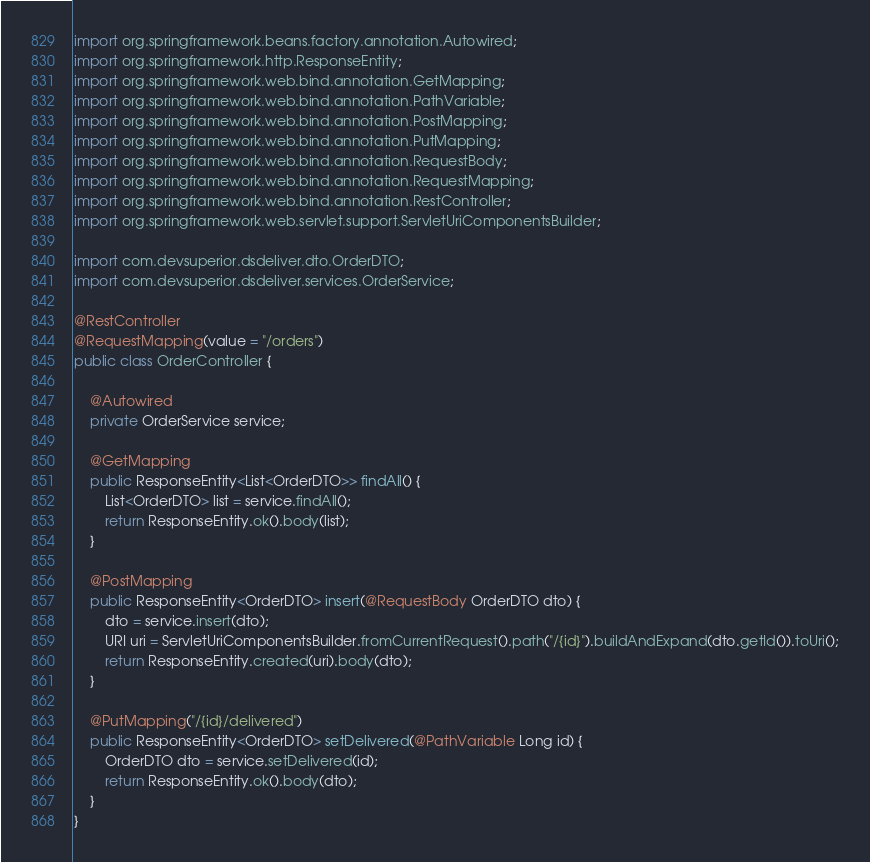<code> <loc_0><loc_0><loc_500><loc_500><_Java_>import org.springframework.beans.factory.annotation.Autowired;
import org.springframework.http.ResponseEntity;
import org.springframework.web.bind.annotation.GetMapping;
import org.springframework.web.bind.annotation.PathVariable;
import org.springframework.web.bind.annotation.PostMapping;
import org.springframework.web.bind.annotation.PutMapping;
import org.springframework.web.bind.annotation.RequestBody;
import org.springframework.web.bind.annotation.RequestMapping;
import org.springframework.web.bind.annotation.RestController;
import org.springframework.web.servlet.support.ServletUriComponentsBuilder;

import com.devsuperior.dsdeliver.dto.OrderDTO;
import com.devsuperior.dsdeliver.services.OrderService;

@RestController
@RequestMapping(value = "/orders")
public class OrderController {

	@Autowired
	private OrderService service;

	@GetMapping
	public ResponseEntity<List<OrderDTO>> findAll() {
		List<OrderDTO> list = service.findAll();
		return ResponseEntity.ok().body(list);
	}

	@PostMapping
	public ResponseEntity<OrderDTO> insert(@RequestBody OrderDTO dto) {
		dto = service.insert(dto);
		URI uri = ServletUriComponentsBuilder.fromCurrentRequest().path("/{id}").buildAndExpand(dto.getId()).toUri();
		return ResponseEntity.created(uri).body(dto);
	}

	@PutMapping("/{id}/delivered")
	public ResponseEntity<OrderDTO> setDelivered(@PathVariable Long id) {
		OrderDTO dto = service.setDelivered(id);
		return ResponseEntity.ok().body(dto);
	}
}
</code> 